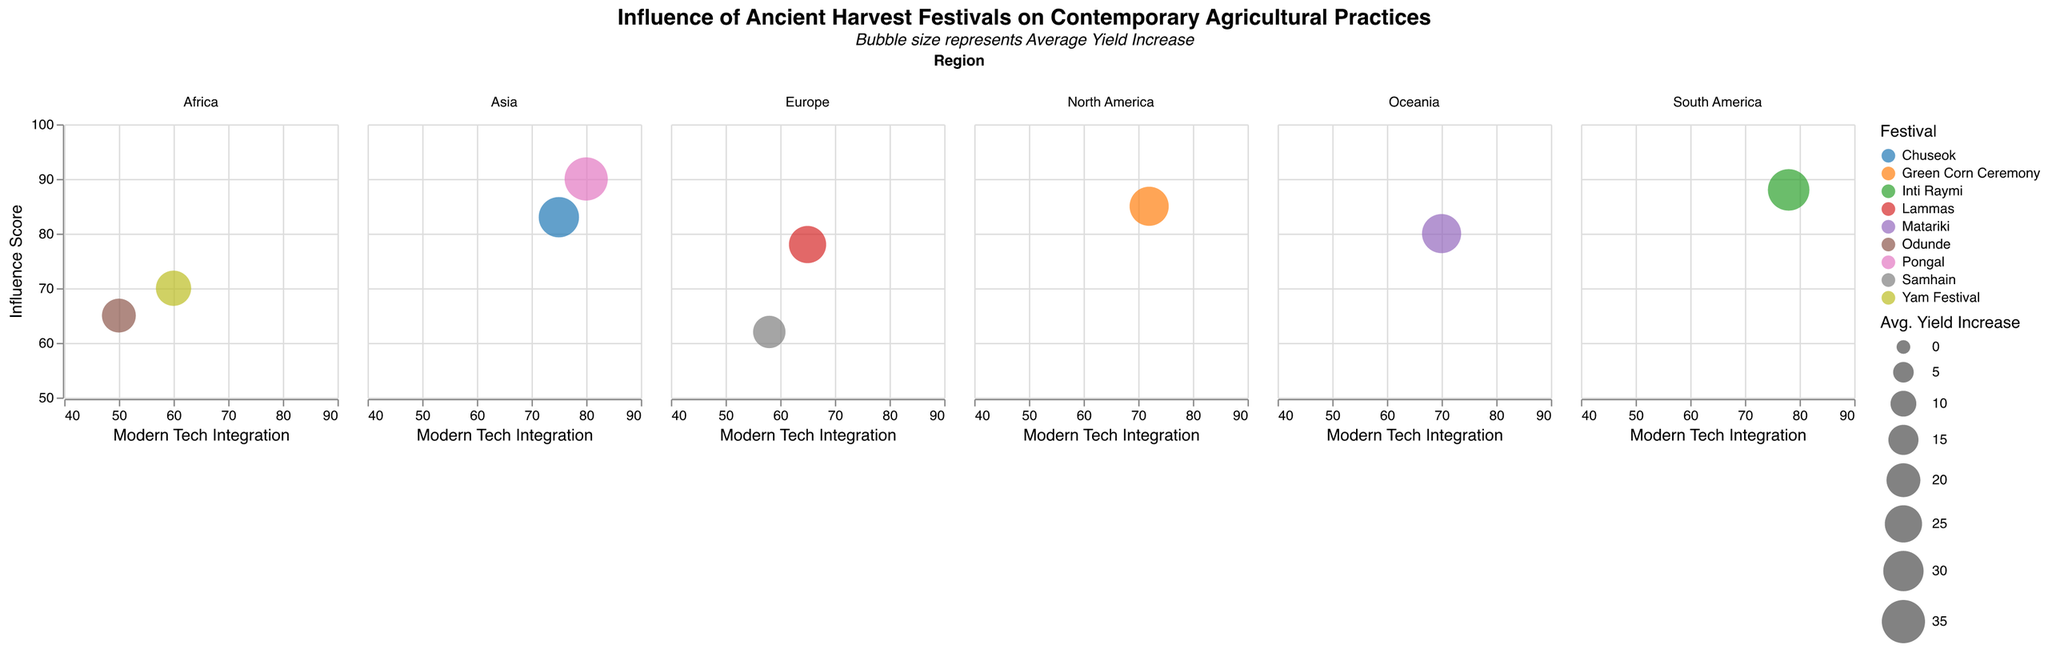What is the title of the figure? The title is located at the top of the figure, usually in a larger and bold font. It provides a general idea of what the figure is about.
Answer: Influence of Ancient Harvest Festivals on Contemporary Agricultural Practices What is the color scheme used to differentiate the festivals? The color scheme is visually represented by different hues for each festival in the color legend. This helps in distinguishing one festival from another.
Answer: category10 How many regions are considered in the plot? In the figure, there are separate sections or columns for each region, clearly labeled across the top. Count these regions to find the total.
Answer: 6 What does the size of each bubble represent? The legend or the explanation near the bubble size indicator provides insight into what the size variable encodes in the figure.
Answer: Average Yield Increase Which festival in North America has the highest Modern Tech Integration score? Look at the North America column and identify the data point (bubble) with the highest value on the x-axis.
Answer: Green Corn Ceremony What is the average Influence Score of the festivals in Asia? Identify the Influence Scores for the festivals in Asia (Chuseok and Pongal), sum them up and divide by the number of festivals. The scores are 83 and 90, respectively. (83 + 90) / 2 = 173 / 2.
Answer: 86.5 What is the total Number of Practices Adopted for the festivals in Europe? Locate the data points for Europe and add the Number of Practices Adopted values for Lammas and Samhain. The values are 15 and 10, respectively. 15 + 10 = 25.
Answer: 25 What is the difference in Average Yield Increase between Inti Raymi in South America and Matariki in Oceania? Find the Average Yield Increase for both Inti Raymi and Matariki, then subtract the smaller value from the larger one. The values are 32 and 28, respectively. 32 - 28.
Answer: 4 What's the median Modern Tech Integration score across all festivals? Collect all Modern Tech Integration scores (65, 58, 75, 80, 60, 50, 72, 78, 70), sort them (50, 58, 60, 65, 70, 72, 75, 78, 80), and find the middle value. The middle value of the sorted list of 9 is the 5th value.
Answer: 70 What is the average Number of Practices Adopted across all regions? Sum the Number of Practices Adopted for all the festivals and divide by the total number of festivals. The sum is 15 + 10 + 20 + 25 + 12 + 10 + 22 + 18 + 15 = 147. There are 9 festivals, so 147 / 9.
Answer: 16.33 Which region has the festival with the highest Influence Score? Compare the Influence Scores for all regions and identify the largest one. Pongal in Asia has the highest score at 90.
Answer: Asia Which region has the most festivals represented in the figure? Count the number of different festivals listed under each region and determine which region has the most. All regions have 1 or 2 festivals.
Answer: Europe, Asia, Africa (tie) Which festival has the highest combined score of Influence Score and Modern Tech Integration? Add the Influence Score and Modern Tech Integration for each festival and find the one with the highest sum. Pongal: 90 + 80 = 170; Compare with others.
Answer: Pongal Which festival in Europe shows the greatest Average Yield Increase? Identify the Average Yield Increase value for Lammas and Samhain, then compare them.
Answer: Lammas What is the difference in Influence Score between Lammas in Europe and the Yam Festival in Africa? Subtract the Influence Score of the Yam Festival from that of Lammas. Lammas = 78, Yam Festival = 70; 78 - 70.
Answer: 8 Which festival has the largest bubble in Asia? Observe the bubble sizes in the Asia region and determine which one appears largest.
Answer: Pongal How do the Influence Scores correlate with Modern Tech Integration scores? Look at the general trend in the plot. If Influence Scores increase with Modern Tech Integration, there is a positive correlation, and vice versa.
Answer: Positive correlation Which festival shows a high Influence Score but relatively low Modern Tech Integration? Identify the data points where the Influence Score is high on the y-axis but the x-axis value is comparatively low.
Answer: Samhain Which region demonstrates the least variability in Influence Scores among its festivals? Compare the spread of Influence Scores within each region to determine which has the smallest range.
Answer: Africa Is there a region where all festivals have an Average Yield Increase greater than 20? Check all listed Average Yield Increases in each region and determine if they are all above 20.
Answer: Asia, South America 